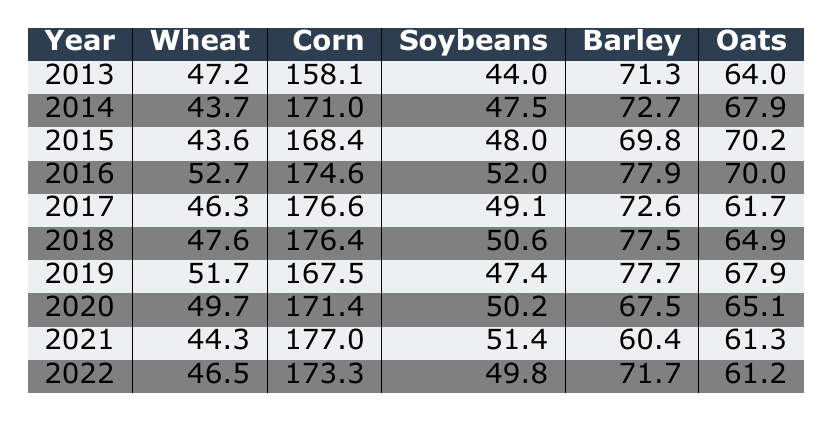What was the corn yield in 2016? Looking at the row for 2016, the corn yield is listed as 174.6 bushels per acre.
Answer: 174.6 Which crop had the highest yield in 2021? In 2021, corn had the highest yield at 177.0 bushels per acre compared to wheat, soybeans, barley, and oats.
Answer: Corn What is the average yield of wheat over the past decade? The yields of wheat from 2013 to 2022 are 47.2, 43.7, 43.6, 52.7, 46.3, 47.6, 51.7, 49.7, 44.3, and 46.5. Adding these gives 474.2, and dividing by 10 yields an average of 47.42.
Answer: 47.42 Did the yield of soybeans increase from 2014 to 2019? In 2014, soybeans had a yield of 47.5, and in 2019 it was 47.4, indicating it did not increase.
Answer: No What was the difference in barley yield between 2016 and 2022? The yield of barley in 2016 was 77.9, and in 2022 it was 71.7. The difference is 77.9 - 71.7 = 6.2.
Answer: 6.2 Was the average yield of oats higher in the later years (2020-2022) compared to the earlier years (2013-2015)? The average yield for oats in 2013-2015 is (64.0 + 67.9 + 70.2) / 3 = 67.33, while in 2020-2022, it's (65.1 + 61.3 + 61.2) / 3 = 62.53. Comparing the two averages shows the earlier years were higher.
Answer: No What crop consistently showed an increase in yield from 2013 to 2016? The wheat yield showed consistent increases from 47.2 in 2013 to 52.7 in 2016.
Answer: Wheat In which year did soybeans have the highest yield? The highest yield for soybeans was in 2016, with a value of 52.0 bushels per acre.
Answer: 2016 